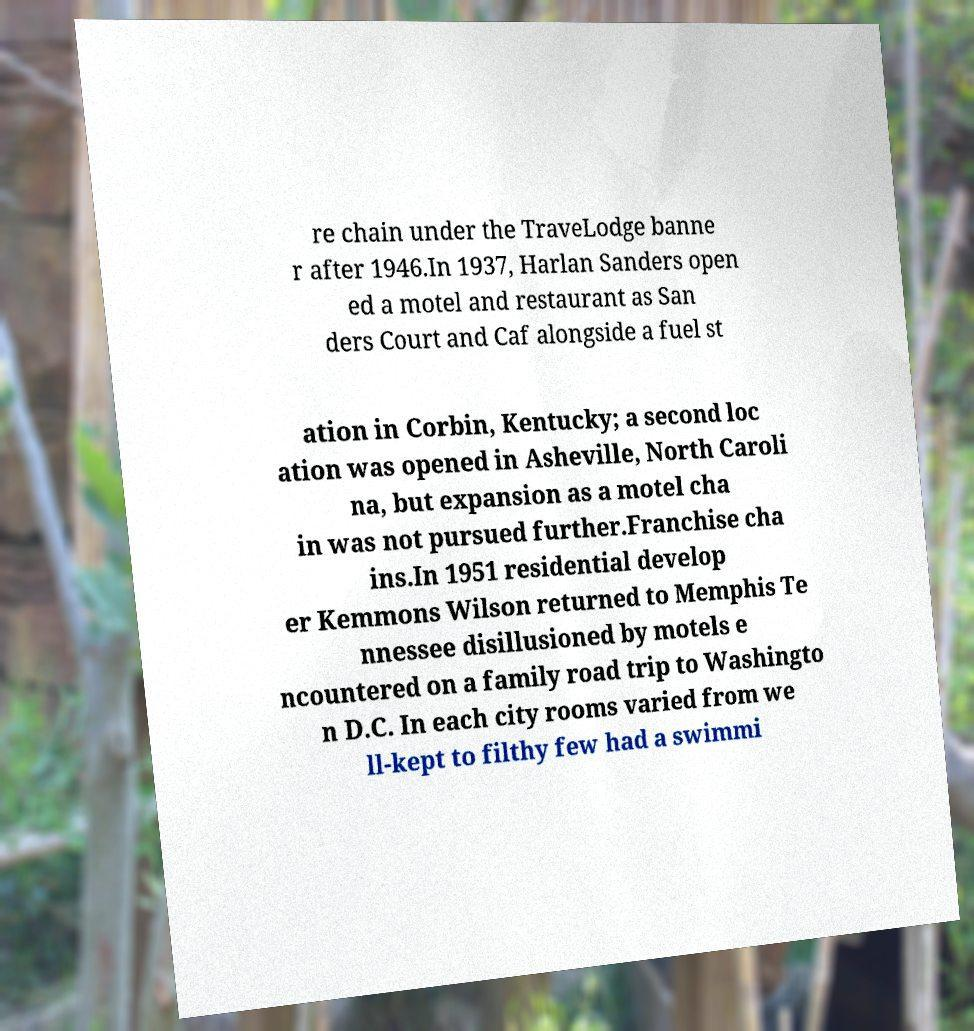Could you assist in decoding the text presented in this image and type it out clearly? re chain under the TraveLodge banne r after 1946.In 1937, Harlan Sanders open ed a motel and restaurant as San ders Court and Caf alongside a fuel st ation in Corbin, Kentucky; a second loc ation was opened in Asheville, North Caroli na, but expansion as a motel cha in was not pursued further.Franchise cha ins.In 1951 residential develop er Kemmons Wilson returned to Memphis Te nnessee disillusioned by motels e ncountered on a family road trip to Washingto n D.C. In each city rooms varied from we ll-kept to filthy few had a swimmi 